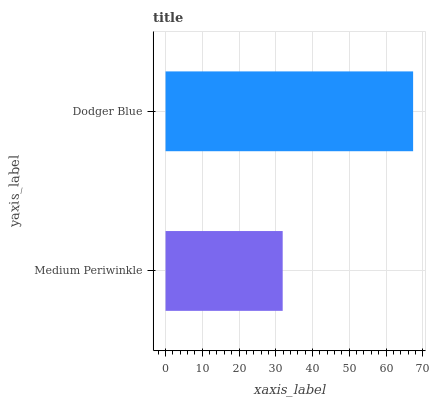Is Medium Periwinkle the minimum?
Answer yes or no. Yes. Is Dodger Blue the maximum?
Answer yes or no. Yes. Is Dodger Blue the minimum?
Answer yes or no. No. Is Dodger Blue greater than Medium Periwinkle?
Answer yes or no. Yes. Is Medium Periwinkle less than Dodger Blue?
Answer yes or no. Yes. Is Medium Periwinkle greater than Dodger Blue?
Answer yes or no. No. Is Dodger Blue less than Medium Periwinkle?
Answer yes or no. No. Is Dodger Blue the high median?
Answer yes or no. Yes. Is Medium Periwinkle the low median?
Answer yes or no. Yes. Is Medium Periwinkle the high median?
Answer yes or no. No. Is Dodger Blue the low median?
Answer yes or no. No. 